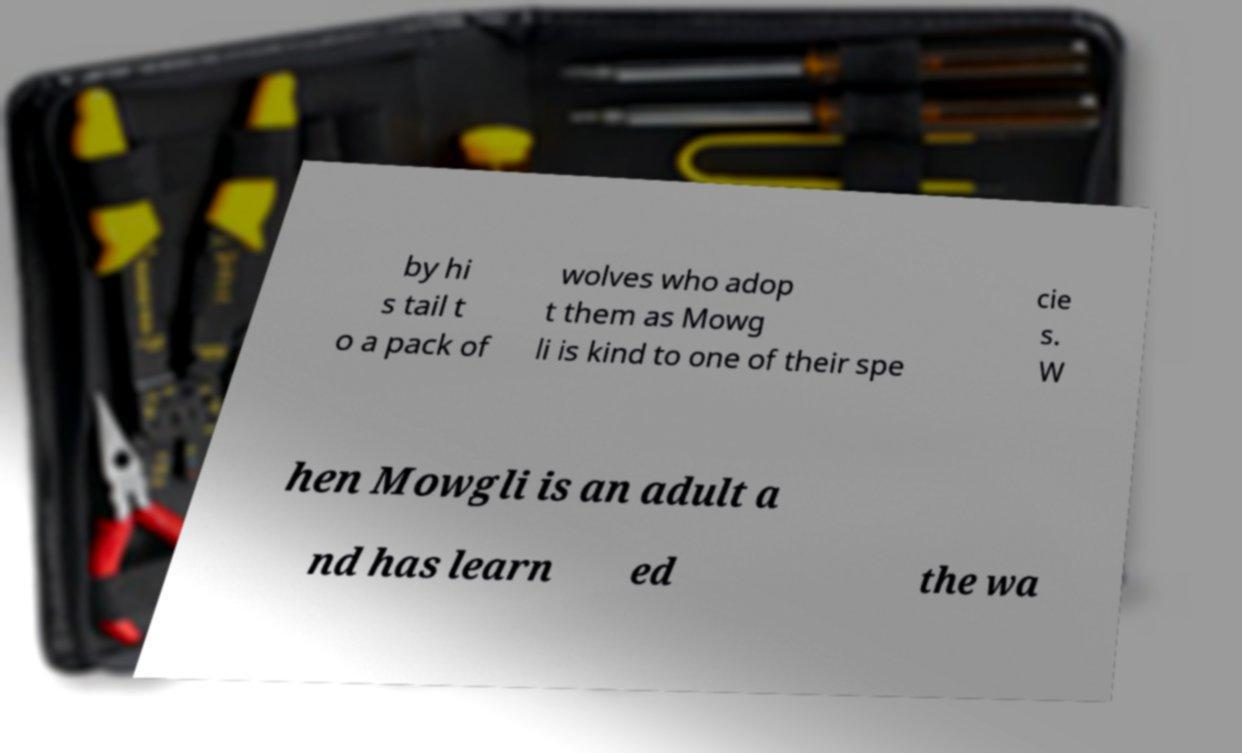There's text embedded in this image that I need extracted. Can you transcribe it verbatim? by hi s tail t o a pack of wolves who adop t them as Mowg li is kind to one of their spe cie s. W hen Mowgli is an adult a nd has learn ed the wa 